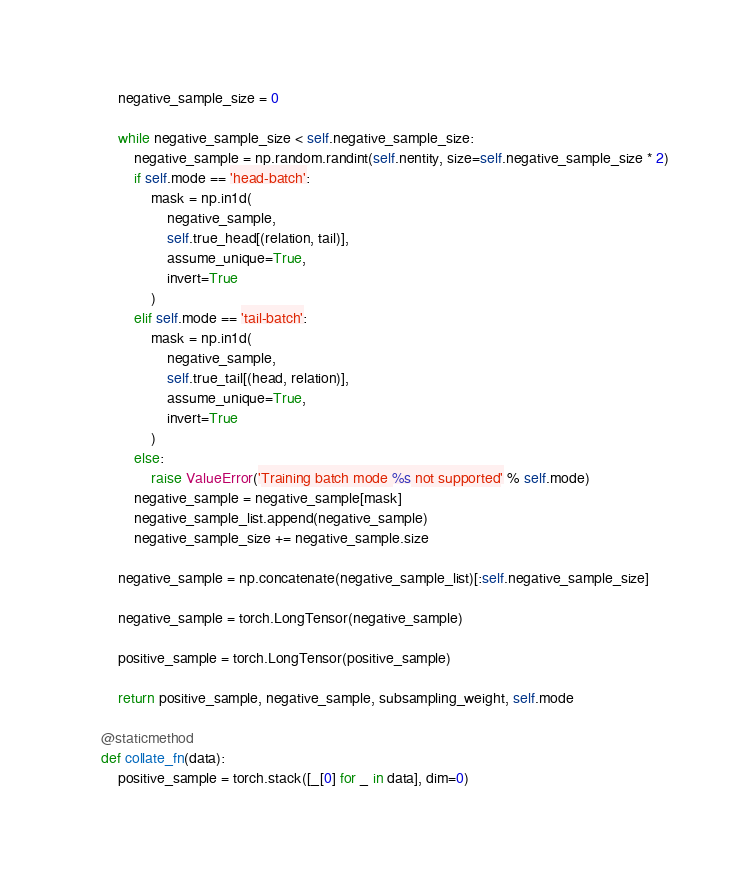<code> <loc_0><loc_0><loc_500><loc_500><_Python_>        negative_sample_size = 0

        while negative_sample_size < self.negative_sample_size:
            negative_sample = np.random.randint(self.nentity, size=self.negative_sample_size * 2)
            if self.mode == 'head-batch':
                mask = np.in1d(
                    negative_sample,
                    self.true_head[(relation, tail)],
                    assume_unique=True,
                    invert=True
                )
            elif self.mode == 'tail-batch':
                mask = np.in1d(
                    negative_sample,
                    self.true_tail[(head, relation)],
                    assume_unique=True,
                    invert=True
                )
            else:
                raise ValueError('Training batch mode %s not supported' % self.mode)
            negative_sample = negative_sample[mask]
            negative_sample_list.append(negative_sample)
            negative_sample_size += negative_sample.size

        negative_sample = np.concatenate(negative_sample_list)[:self.negative_sample_size]

        negative_sample = torch.LongTensor(negative_sample)

        positive_sample = torch.LongTensor(positive_sample)

        return positive_sample, negative_sample, subsampling_weight, self.mode

    @staticmethod
    def collate_fn(data):
        positive_sample = torch.stack([_[0] for _ in data], dim=0)</code> 